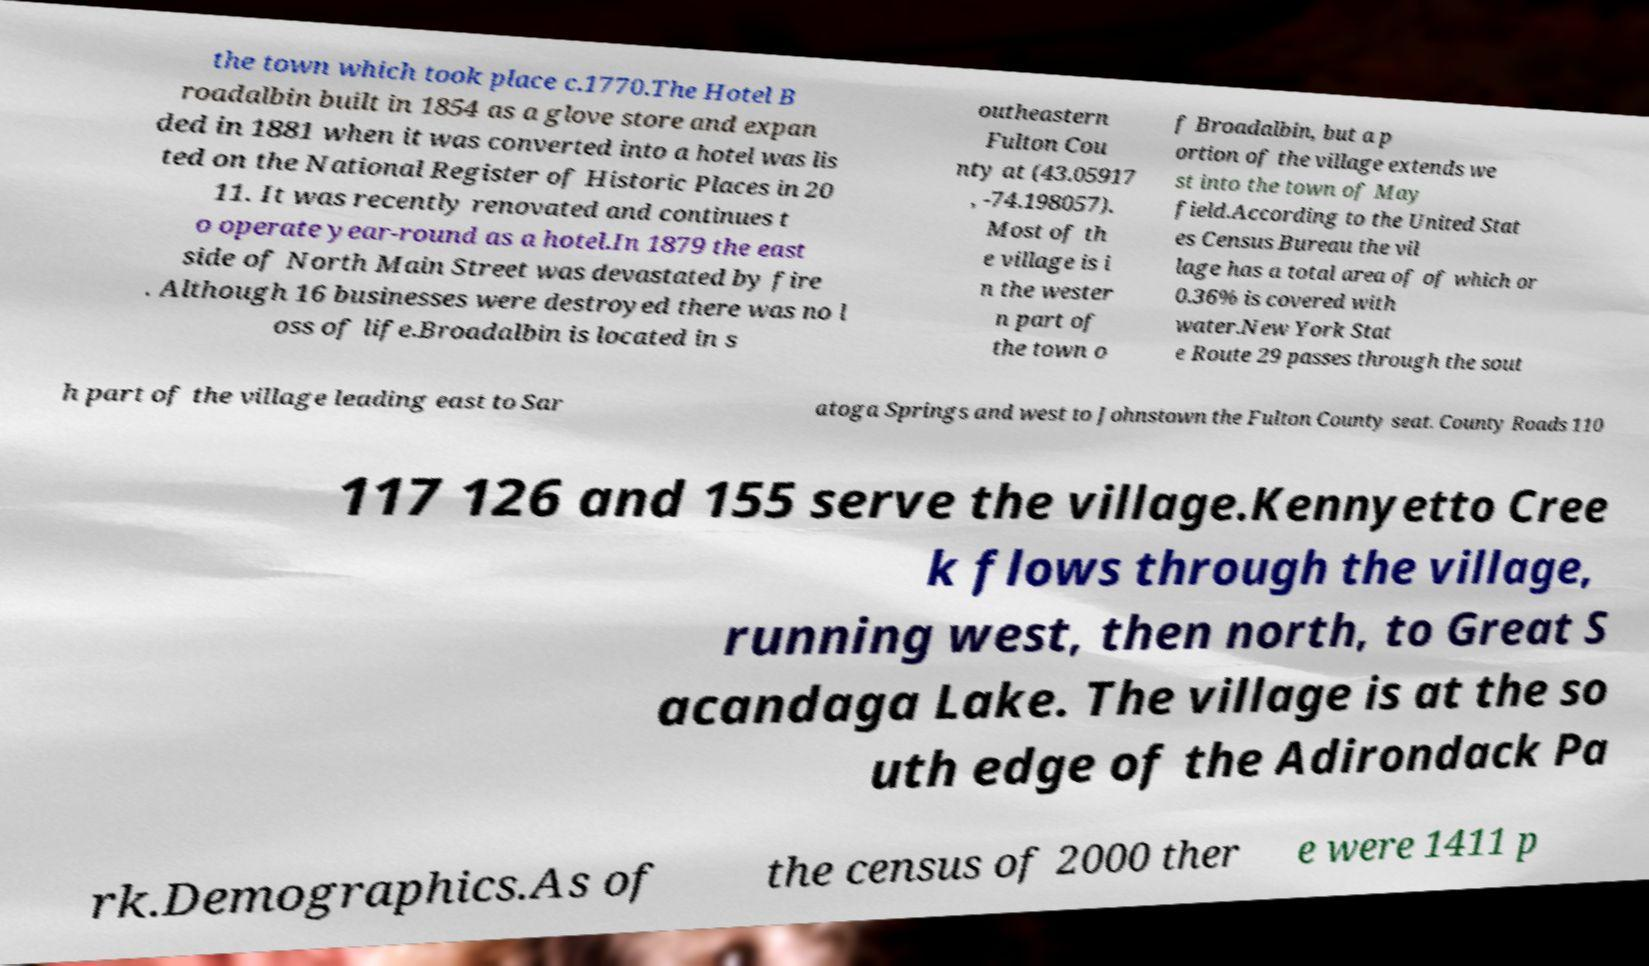Could you extract and type out the text from this image? the town which took place c.1770.The Hotel B roadalbin built in 1854 as a glove store and expan ded in 1881 when it was converted into a hotel was lis ted on the National Register of Historic Places in 20 11. It was recently renovated and continues t o operate year-round as a hotel.In 1879 the east side of North Main Street was devastated by fire . Although 16 businesses were destroyed there was no l oss of life.Broadalbin is located in s outheastern Fulton Cou nty at (43.05917 , -74.198057). Most of th e village is i n the wester n part of the town o f Broadalbin, but a p ortion of the village extends we st into the town of May field.According to the United Stat es Census Bureau the vil lage has a total area of of which or 0.36% is covered with water.New York Stat e Route 29 passes through the sout h part of the village leading east to Sar atoga Springs and west to Johnstown the Fulton County seat. County Roads 110 117 126 and 155 serve the village.Kennyetto Cree k flows through the village, running west, then north, to Great S acandaga Lake. The village is at the so uth edge of the Adirondack Pa rk.Demographics.As of the census of 2000 ther e were 1411 p 